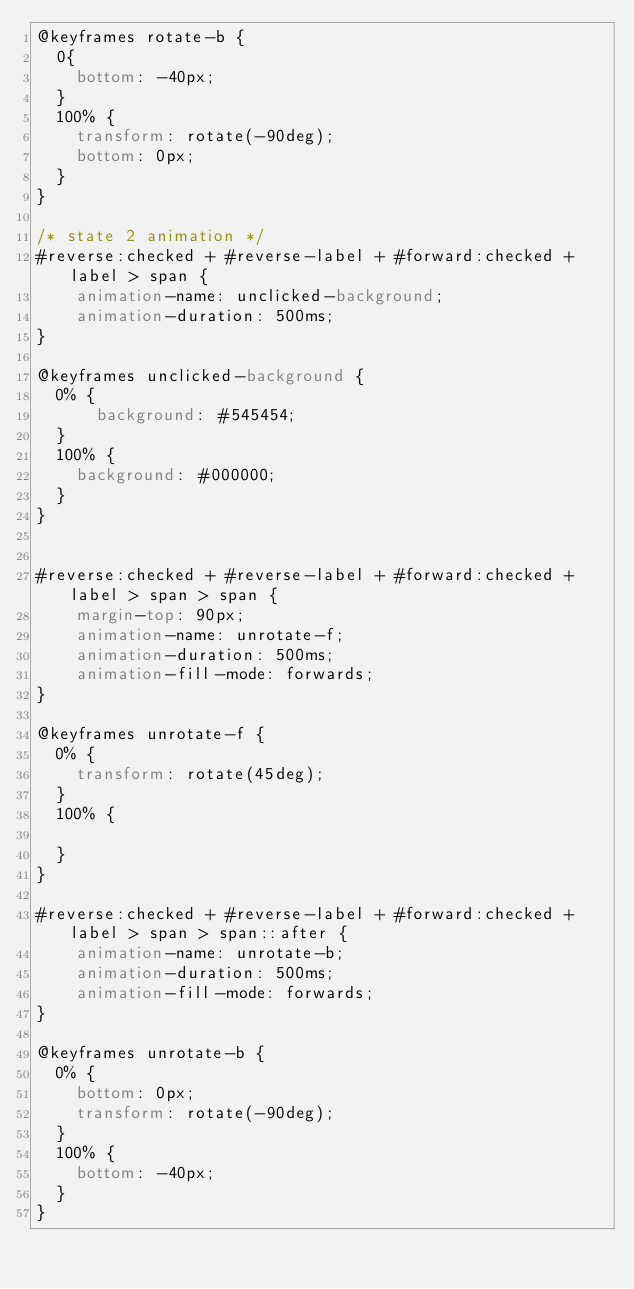<code> <loc_0><loc_0><loc_500><loc_500><_CSS_>@keyframes rotate-b {
  0{
    bottom: -40px;
  }
  100% {
    transform: rotate(-90deg);
    bottom: 0px;
  }
}

/* state 2 animation */
#reverse:checked + #reverse-label + #forward:checked + label > span {
    animation-name: unclicked-background;
    animation-duration: 500ms;
}

@keyframes unclicked-background {
  0% {
      background: #545454;
  }
  100% {
    background: #000000;
  }
}


#reverse:checked + #reverse-label + #forward:checked + label > span > span {
    margin-top: 90px;
    animation-name: unrotate-f;
    animation-duration: 500ms;
    animation-fill-mode: forwards;
}

@keyframes unrotate-f {
  0% {
    transform: rotate(45deg);
  }
  100% {
    
  }
}

#reverse:checked + #reverse-label + #forward:checked + label > span > span::after {
    animation-name: unrotate-b;
    animation-duration: 500ms;
    animation-fill-mode: forwards;
}

@keyframes unrotate-b {
  0% {
    bottom: 0px;
    transform: rotate(-90deg);
  }
  100% {
    bottom: -40px;
  }
}</code> 